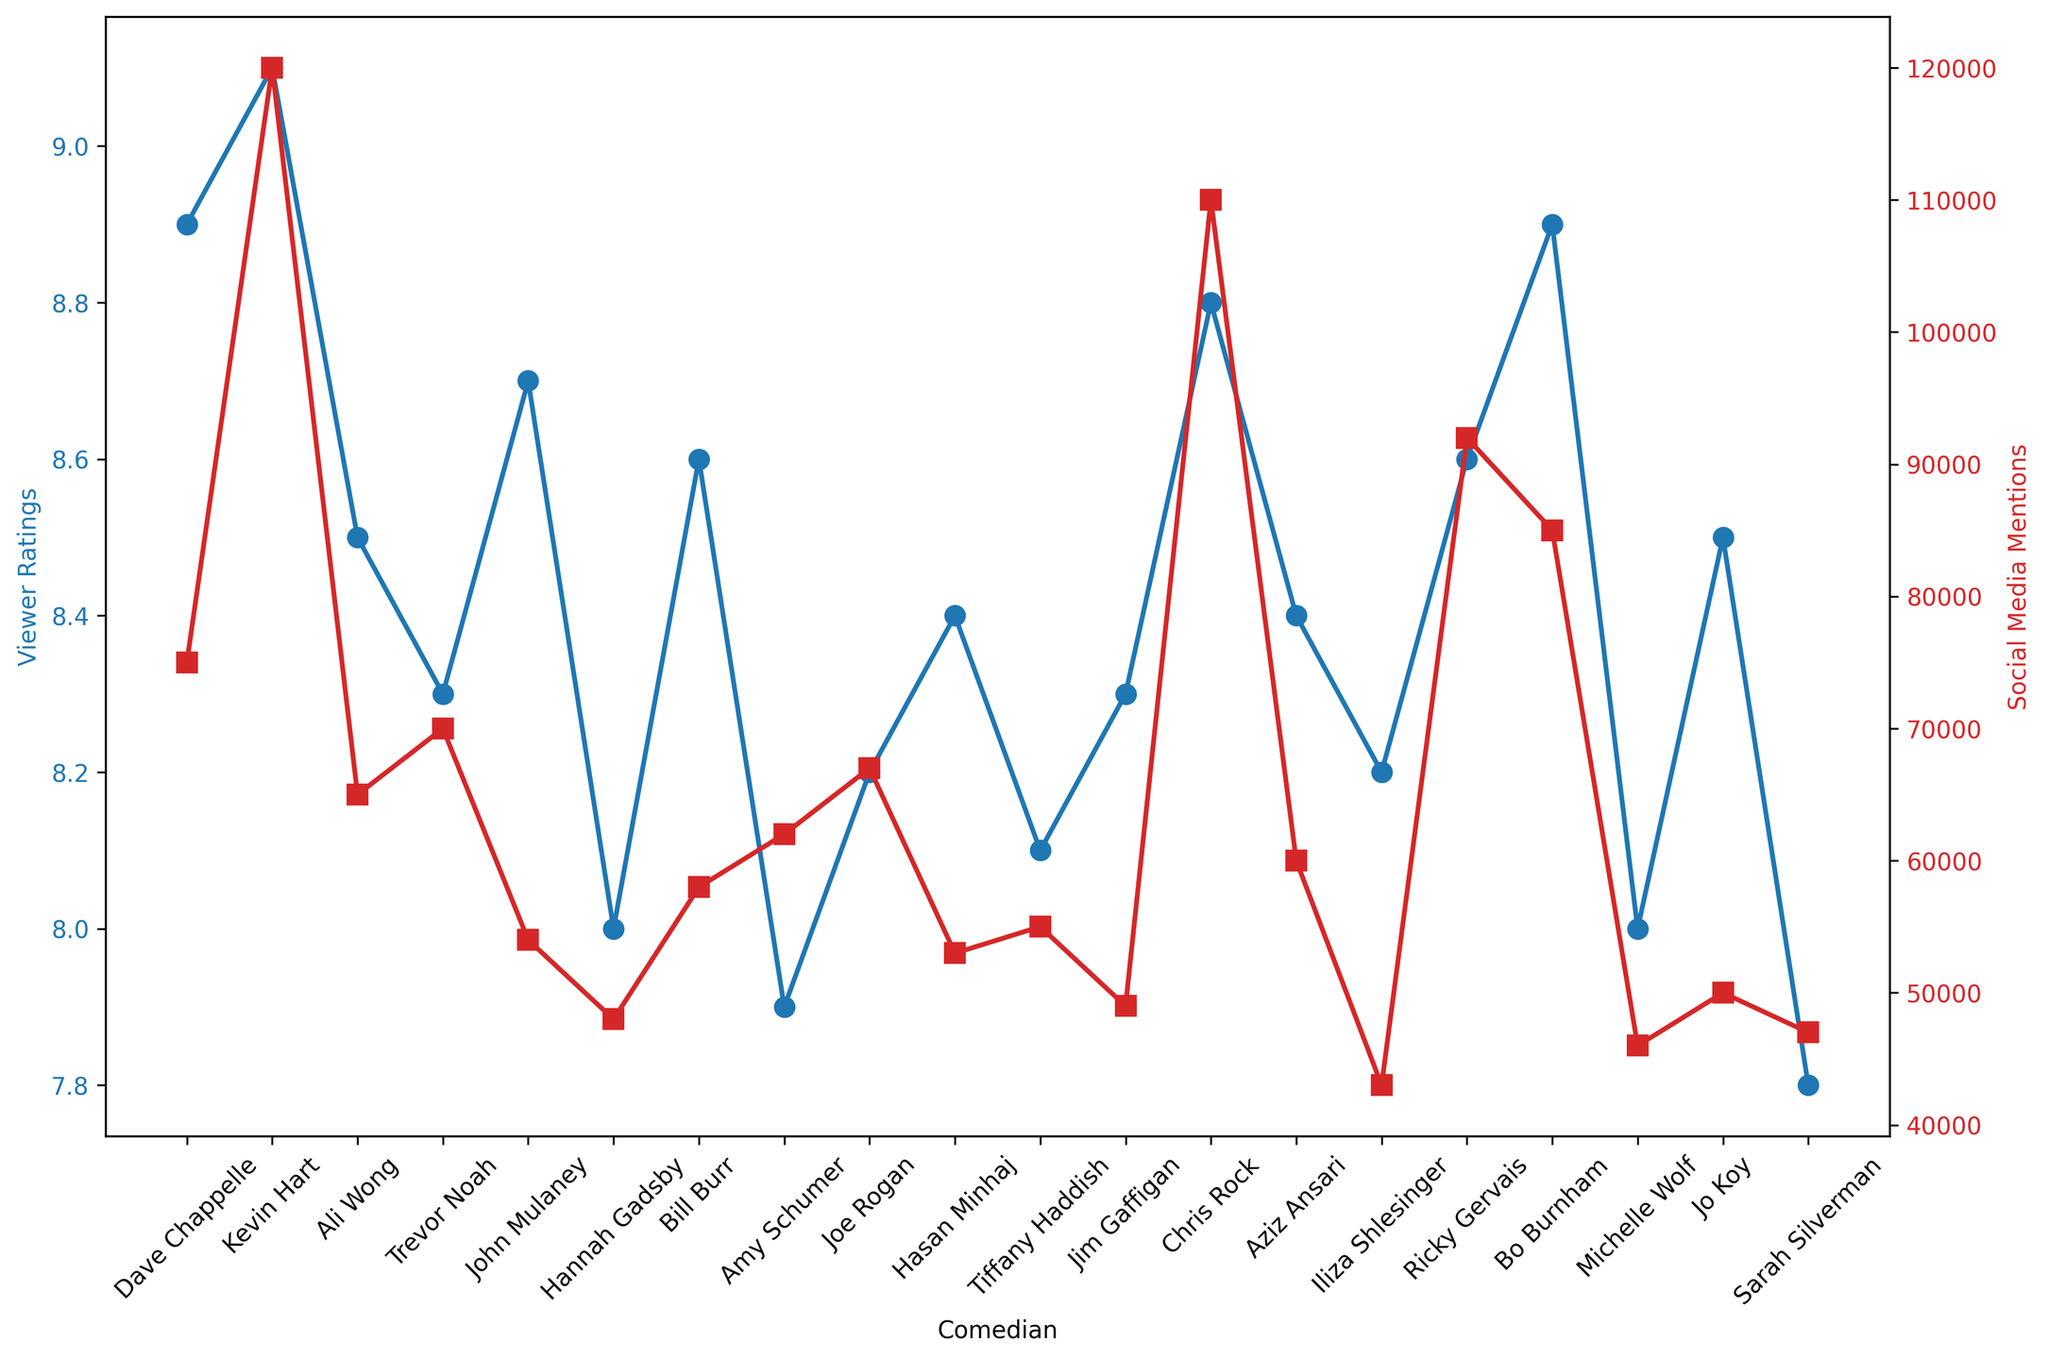Which comedian has the highest viewer ratings? The plot indicates that Kevin Hart has the highest viewer ratings as his data point is the highest on the blue plot line.
Answer: Kevin Hart Which comedian has the most social media mentions? By examining the red plot line, Kevin Hart has the tallest peak, indicating he has the most social media mentions.
Answer: Kevin Hart Compare the viewer ratings of Dave Chappelle and Bo Burnham. Who has higher ratings? Both data points for viewer ratings should be checked in the blue plot line, and Dave Chappelle and Bo Burnham both have the same viewer ratings of 8.9.
Answer: Equal Who has the least social media mentions among Ali Wong, Aziz Ansari, and Michelle Wolf? By comparing the heights of their respective data points on the red plot line, Michelle Wolf has the lowest point, indicating the fewest social media mentions.
Answer: Michelle Wolf What is the average viewer rating of Hannah Gadsby, Michelle Wolf, and Sarah Silverman? Add their ratings: 8.0 + 8.0 + 7.8 = 23.8, then divide by 3, which results in 23.8/3 = 7.93.
Answer: 7.93 Which comedian has higher social media mentions, Hasan Minhaj or Amy Schumer? Comparing their respective heights in the red plot line, Amy Schumer's data point is higher than Hasan Minhaj's.
Answer: Amy Schumer What's the difference in viewer ratings between Trevor Noah and Chris Rock? Subtract Trevor Noah's rating from Chris Rock's: 8.8 - 8.3 = 0.5.
Answer: 0.5 Identify the comedians with social media mentions greater than 100,000. By observing the red plot line, comedians with data points above the 100,000 mark are Kevin Hart and Chris Rock.
Answer: Kevin Hart, Chris Rock Which comedian has a viewer rating closest to the median rating of all comedians? The median rating should be determined first. Sorting the ratings, the middle value is the median. Since there are 20 comedians, the median is the average of the 10th and 11th. The median of 8.4 (Hasan Minhaj) and 8.5 (Jo Koy) is 8.45. Comedian with a rating closest to 8.45 is Joe Rogan with 8.4.
Answer: Hasan Minhaj Compare the social media mentions to viewer ratings for Bill Burr. Which is higher? Bill Burr's viewer ratings (8.6) can be compared to his social media mentions (58,000). His viewer ratings are higher.
Answer: Viewer ratings 